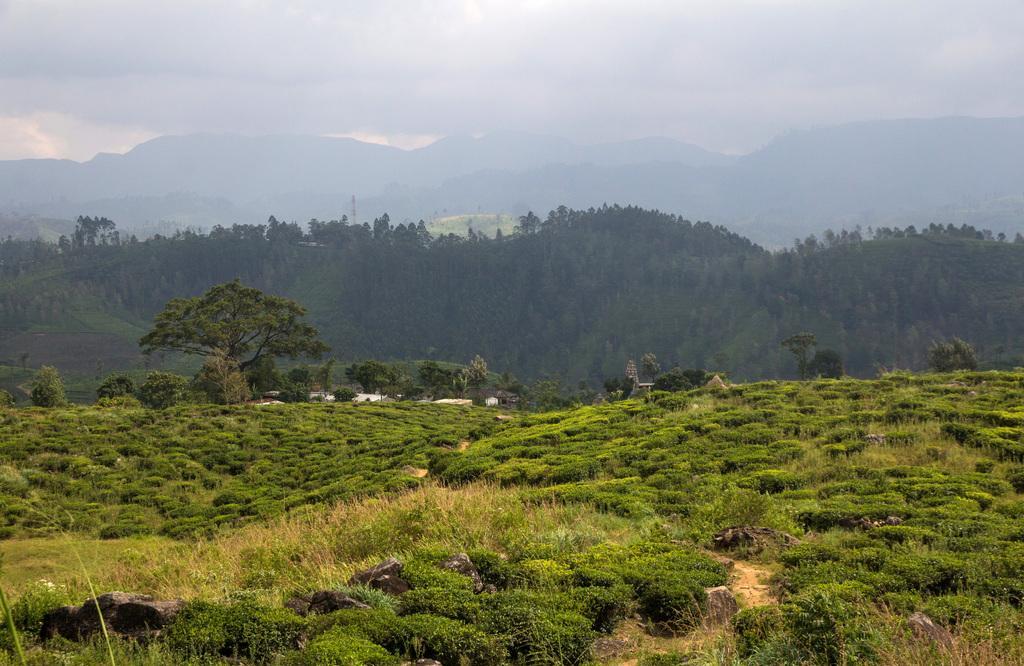Describe this image in one or two sentences. In this image we can see a group of trees, mountains and in the background we can see the sky. 